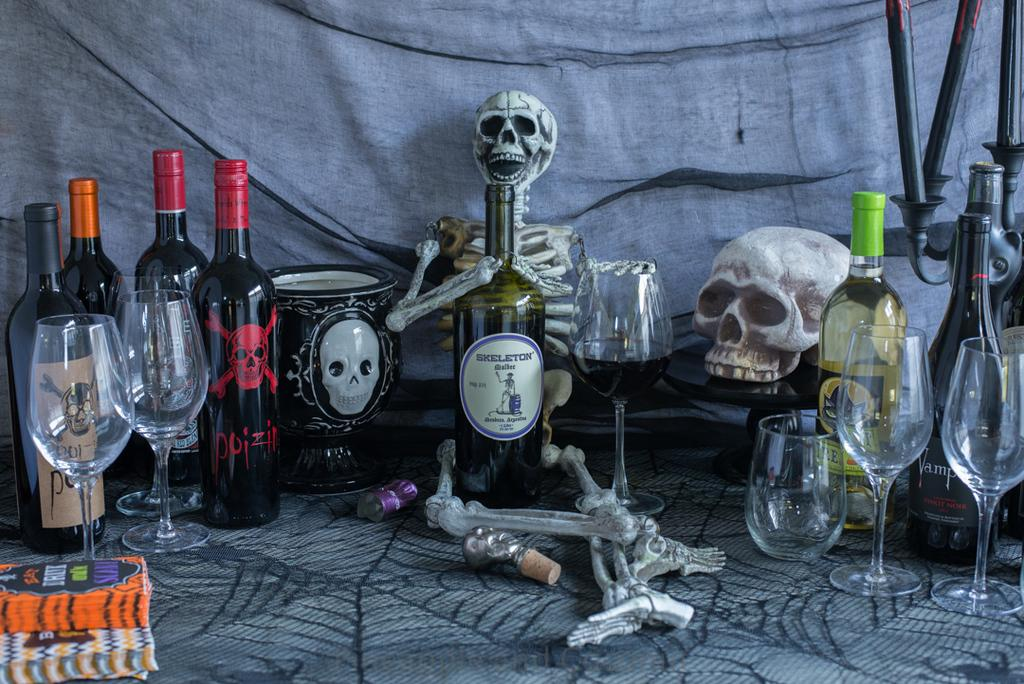What is covering the table in the image? There is a spider web cloth on the table. What types of containers are on the table? There are bottles and glasses on the table. What else can be found on the table? There is a book and a skeleton on the table. What is visible in the background of the image? There is a cloth in the background of the image. Can you see any airplanes taking off at the airport in the image? There is no airport or airplanes present in the image. What type of bird is sitting on the skeleton in the image? There is no bird, specifically a robin, present in the image. 